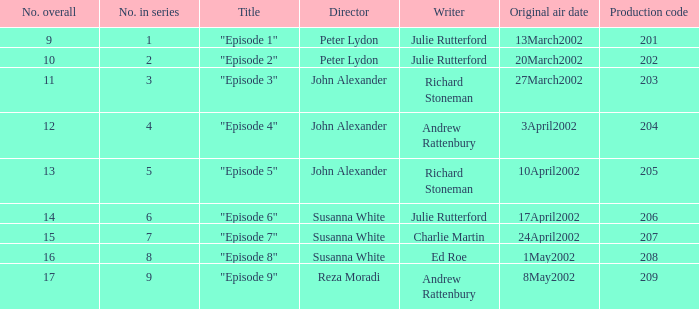When 1 is the number in series who is the director? Peter Lydon. 